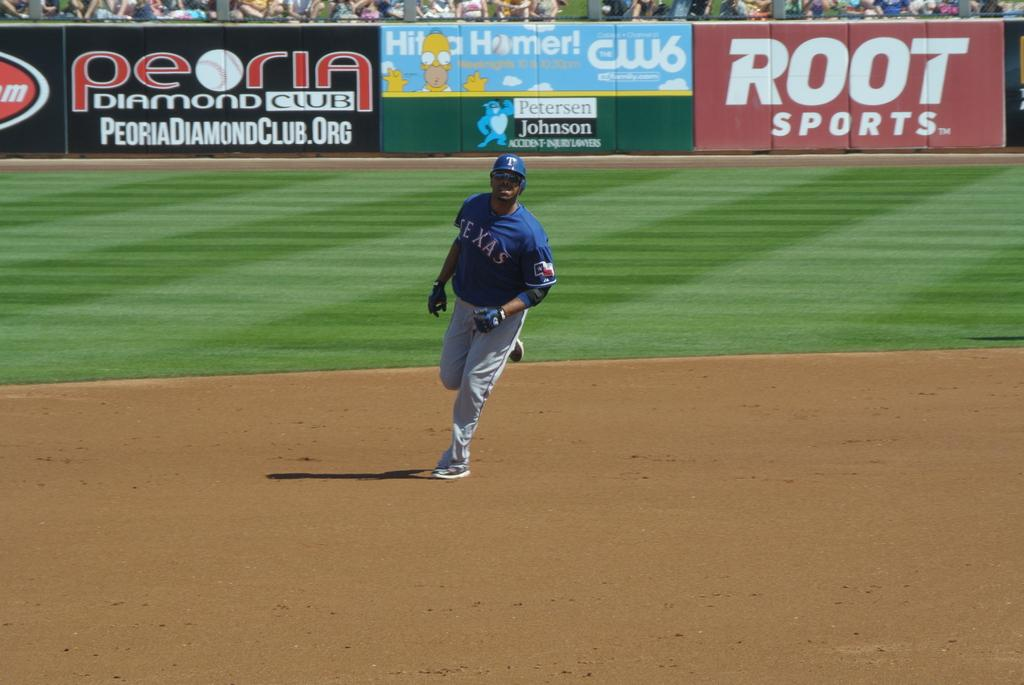<image>
Relay a brief, clear account of the picture shown. a person on a baseball field with a TEXAS jersey 